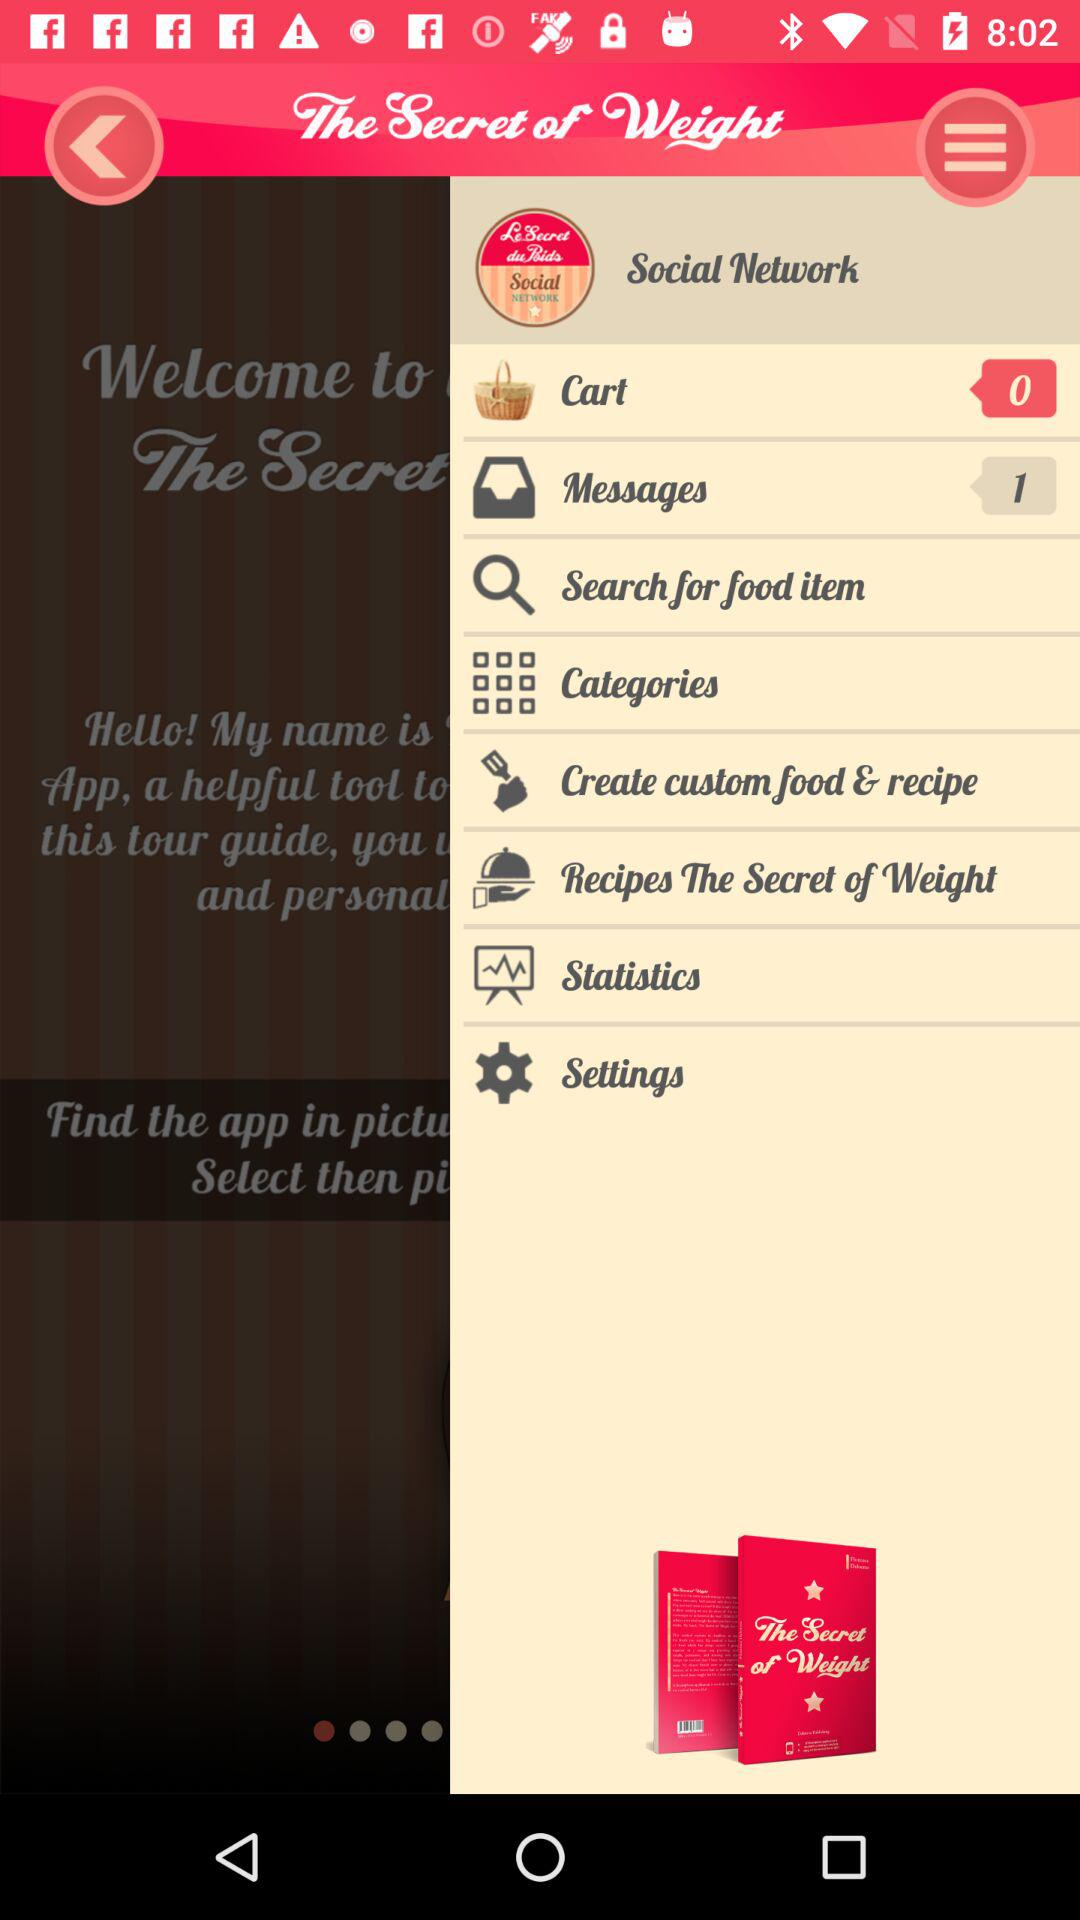How many things are in the cart? There are 0 things in the cart. 